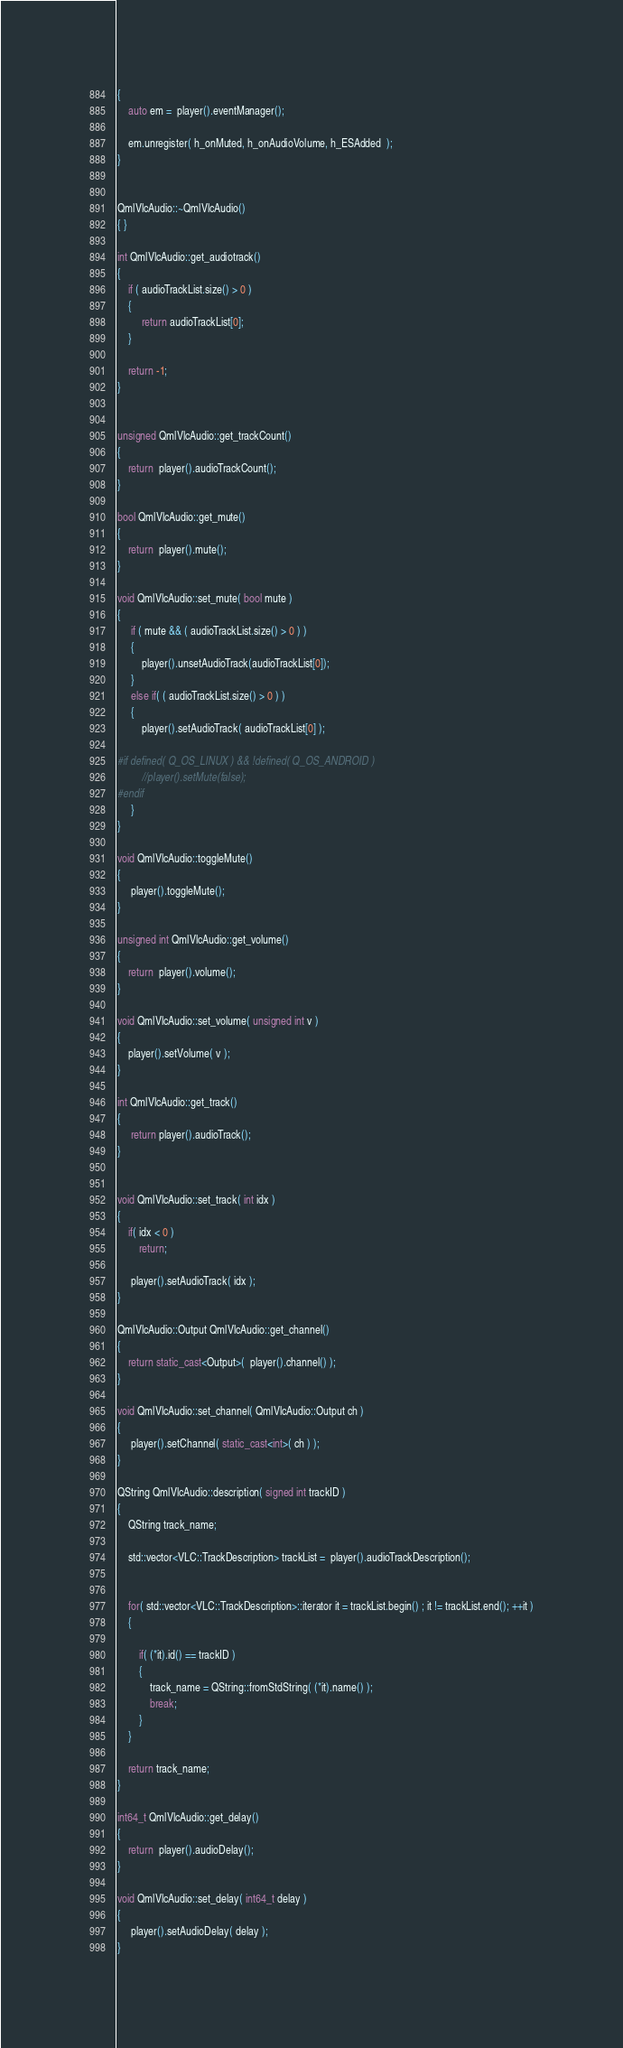<code> <loc_0><loc_0><loc_500><loc_500><_C++_>{
    auto em =  player().eventManager();

    em.unregister( h_onMuted, h_onAudioVolume, h_ESAdded  );
}


QmlVlcAudio::~QmlVlcAudio()
{ }

int QmlVlcAudio::get_audiotrack()
{
    if ( audioTrackList.size() > 0 )
    {
         return audioTrackList[0];
    }

    return -1;
}


unsigned QmlVlcAudio::get_trackCount()
{
    return  player().audioTrackCount();
}

bool QmlVlcAudio::get_mute()
{
    return  player().mute();
}

void QmlVlcAudio::set_mute( bool mute )
{
     if ( mute && ( audioTrackList.size() > 0 ) )
     {
         player().unsetAudioTrack(audioTrackList[0]);
     }
     else if( ( audioTrackList.size() > 0 ) )
     {
         player().setAudioTrack( audioTrackList[0] );

#if defined( Q_OS_LINUX ) && !defined( Q_OS_ANDROID )
         //player().setMute(false);
#endif
     }
}

void QmlVlcAudio::toggleMute()
{
     player().toggleMute();
}

unsigned int QmlVlcAudio::get_volume()
{
    return  player().volume();
}

void QmlVlcAudio::set_volume( unsigned int v )
{
    player().setVolume( v );
}

int QmlVlcAudio::get_track()
{
     return player().audioTrack();
}


void QmlVlcAudio::set_track( int idx )
{
    if( idx < 0 )
        return;

     player().setAudioTrack( idx );
}

QmlVlcAudio::Output QmlVlcAudio::get_channel()
{
    return static_cast<Output>(  player().channel() );
}

void QmlVlcAudio::set_channel( QmlVlcAudio::Output ch )
{
     player().setChannel( static_cast<int>( ch ) );
}

QString QmlVlcAudio::description( signed int trackID )
{
    QString track_name;

    std::vector<VLC::TrackDescription> trackList =  player().audioTrackDescription();


    for( std::vector<VLC::TrackDescription>::iterator it = trackList.begin() ; it != trackList.end(); ++it )
    {

        if( (*it).id() == trackID )
        {
            track_name = QString::fromStdString( (*it).name() );
            break;
        }
    }

    return track_name;
}

int64_t QmlVlcAudio::get_delay()
{
    return  player().audioDelay();
}

void QmlVlcAudio::set_delay( int64_t delay )
{
     player().setAudioDelay( delay );
}
</code> 